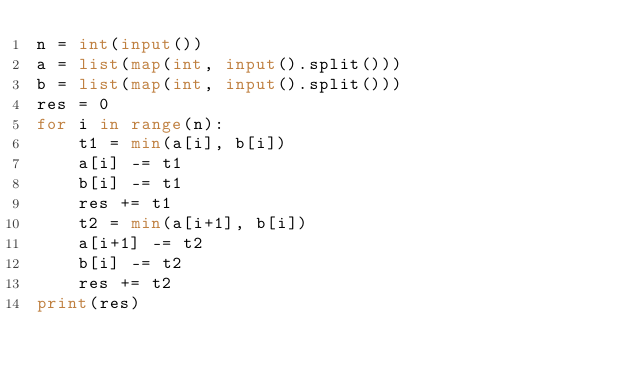<code> <loc_0><loc_0><loc_500><loc_500><_Python_>n = int(input())
a = list(map(int, input().split()))
b = list(map(int, input().split()))
res = 0
for i in range(n):
    t1 = min(a[i], b[i])
    a[i] -= t1
    b[i] -= t1
    res += t1
    t2 = min(a[i+1], b[i])
    a[i+1] -= t2
    b[i] -= t2
    res += t2
print(res)
</code> 